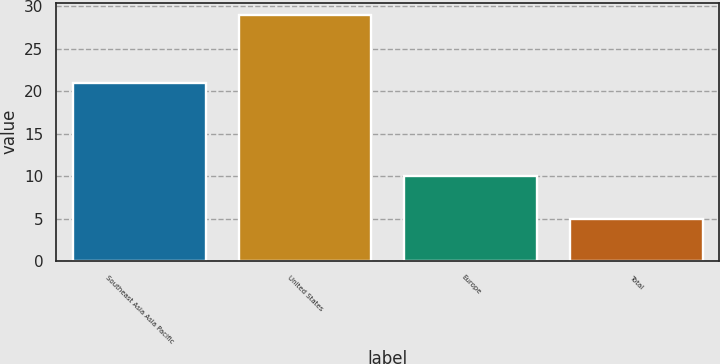Convert chart to OTSL. <chart><loc_0><loc_0><loc_500><loc_500><bar_chart><fcel>Southeast Asia Asia Pacific<fcel>United States<fcel>Europe<fcel>Total<nl><fcel>21<fcel>29<fcel>10<fcel>5<nl></chart> 